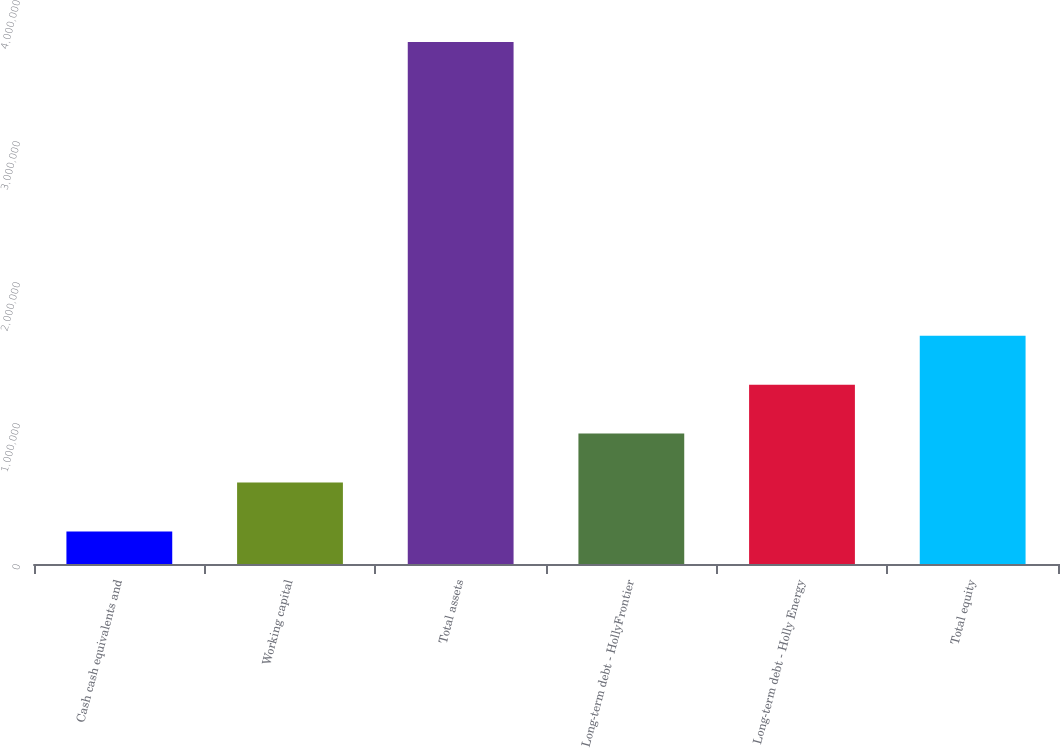<chart> <loc_0><loc_0><loc_500><loc_500><bar_chart><fcel>Cash cash equivalents and<fcel>Working capital<fcel>Total assets<fcel>Long-term debt - HollyFrontier<fcel>Long-term debt - Holly Energy<fcel>Total equity<nl><fcel>230444<fcel>577547<fcel>3.70148e+06<fcel>924650<fcel>1.27175e+06<fcel>1.61886e+06<nl></chart> 